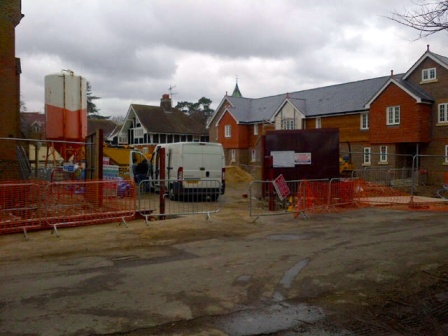Can you tell me what safety measures are in place at this construction site? The construction site appears to follow several safety protocols. The red safety fencing around the perimeter indicates a clear boundary that restricts unauthorized access. Additionally, there are signs, though not readable, suggesting there are probably warnings or instructions related to safety. The placement of large machinery within fenced areas also helps in maintaining a buffer zone between heavy equipment and workers or bystanders. What do you think the main challenge of working on this site might be? One of the main challenges of working on this construction site could be managing the logistics and safety of heavy machinery in a relatively confined space. Coordinating the different stages of house construction in close proximity might also pose significant project management challenges. Ensuring safety while operating large vehicles, maintaining clear communication among workers, and adhering to timelines despite potential weather-related delays due to the cloudy conditions could be additional challenges. Imagine the construction site comes alive at night. Describe how it might look with all the machinery operating under artificial lights. As night falls, the construction site transforms into a symphony of activity under the glow of bright artificial lights. Large floodlights tower above, casting a stark, almost surreal luminescence on the scene. The orange and white of the construction machinery gleam under the lights as they rumble and move purposefully, their engines humming a mechanical tune. The reflective surfaces on safety helmets and vests of the workers glint as they hurry about their tasks. Amidst the organized chaos, small puffs of dust and occasional sparks create an ethereal atmosphere, contrasting the tranquility of the sleeping neighborhood beyond the fence. A robot visits the site at night with the capability to complete the entire construction in one night. Describe the scenario in detail. In the dead of night, as the wind whispers secrets to the silent neighborhood, a sleek, state-of-the-art construction robot arrives at the site. Standing tall with multiple articulated arms, it exudes an aura of futuristic efficiency. As it starts its work, its movements are precise and fluid, almost mesmerizing. The robot's arms extend to lift heavy beams effortlessly into place, its welding tools sparking vividly as it joins metal structures with perfect accuracy. Its vast array of sensors and AI guides it flawlessly through the construction blueprints. As hours pass, what was once a chaotic arrangement of raw materials and partially-built structures evolves rapidly into completed homes. By dawn, the construction site stands transformed—quiet and orderly, with brand-new houses lining the street, a testament to the robot's unparalleled capabilities. 